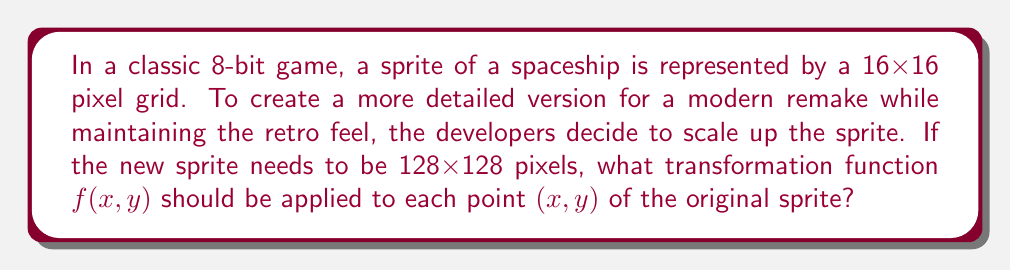Give your solution to this math problem. To solve this problem, we need to determine the scaling factor and then express it as a transformation function.

1) First, let's calculate the scaling factor:
   Original size: 16x16 pixels
   New size: 128x128 pixels
   
   Scaling factor = 128 ÷ 16 = 8

2) This means each dimension (both x and y) needs to be multiplied by 8.

3) In mathematical terms, this scaling can be expressed as a transformation function:

   $f(x,y) = (8x, 8y)$

4) This function takes each point $(x,y)$ of the original sprite and maps it to a new point $(8x, 8y)$ in the scaled-up version.

5) We can also express this as a matrix transformation:

   $$\begin{pmatrix} 8 & 0 \\ 0 & 8 \end{pmatrix} \begin{pmatrix} x \\ y \end{pmatrix} = \begin{pmatrix} 8x \\ 8y \end{pmatrix}$$

This transformation will enlarge the sprite while maintaining its proportions and pixelated appearance, preserving the retro feel in the more detailed version.
Answer: $f(x,y) = (8x, 8y)$ 